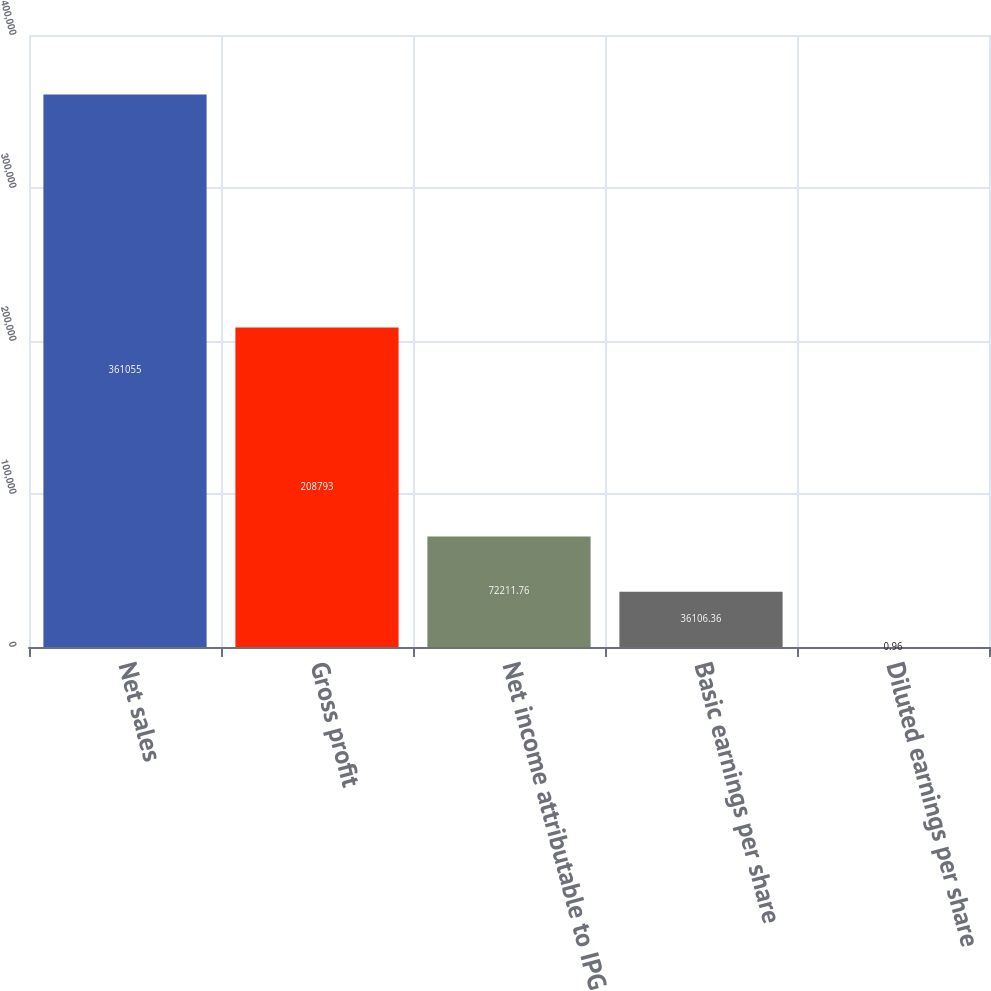Convert chart. <chart><loc_0><loc_0><loc_500><loc_500><bar_chart><fcel>Net sales<fcel>Gross profit<fcel>Net income attributable to IPG<fcel>Basic earnings per share<fcel>Diluted earnings per share<nl><fcel>361055<fcel>208793<fcel>72211.8<fcel>36106.4<fcel>0.96<nl></chart> 